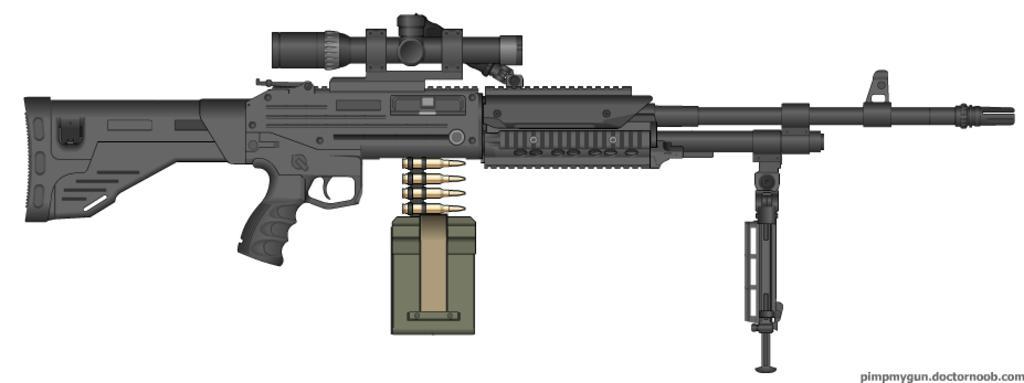Describe this image in one or two sentences. In the picture I can see a gun. I can also see something written on the image. The background of the image is white in color. 